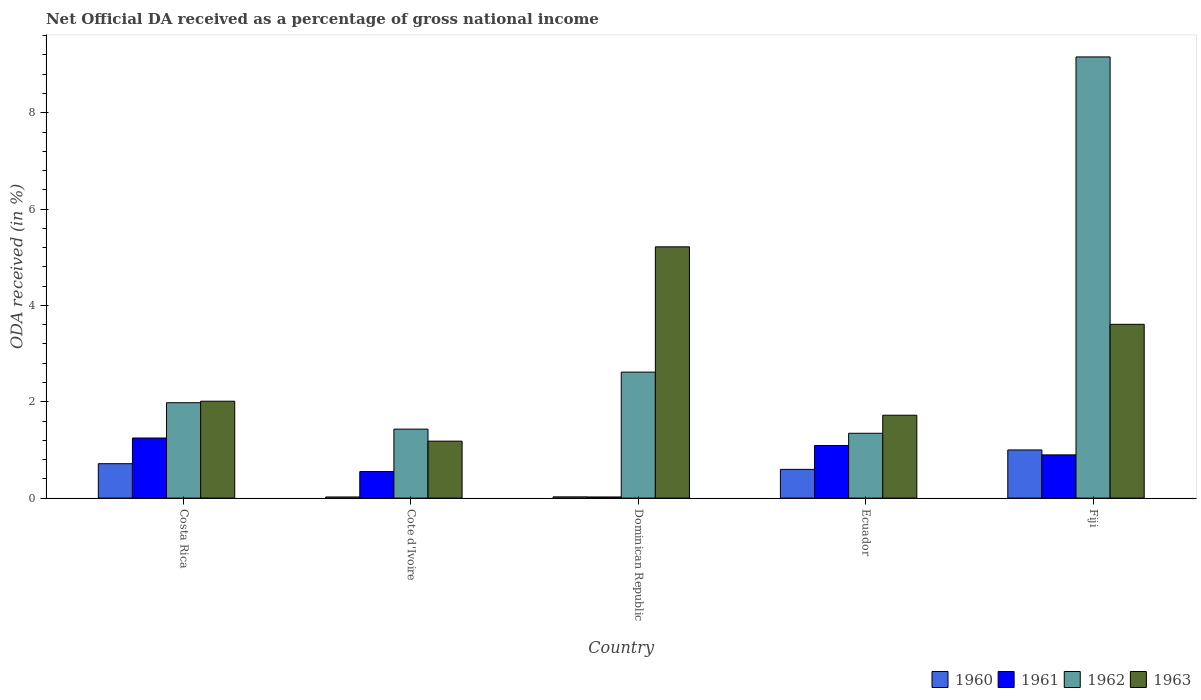How many groups of bars are there?
Keep it short and to the point. 5. Are the number of bars on each tick of the X-axis equal?
Offer a terse response. Yes. How many bars are there on the 1st tick from the right?
Your response must be concise. 4. What is the net official DA received in 1962 in Ecuador?
Offer a very short reply. 1.35. Across all countries, what is the maximum net official DA received in 1961?
Keep it short and to the point. 1.25. Across all countries, what is the minimum net official DA received in 1960?
Provide a short and direct response. 0.02. In which country was the net official DA received in 1960 maximum?
Provide a succinct answer. Fiji. In which country was the net official DA received in 1963 minimum?
Give a very brief answer. Cote d'Ivoire. What is the total net official DA received in 1963 in the graph?
Your answer should be compact. 13.74. What is the difference between the net official DA received in 1960 in Costa Rica and that in Dominican Republic?
Make the answer very short. 0.69. What is the difference between the net official DA received in 1960 in Dominican Republic and the net official DA received in 1963 in Cote d'Ivoire?
Your response must be concise. -1.16. What is the average net official DA received in 1963 per country?
Ensure brevity in your answer.  2.75. What is the difference between the net official DA received of/in 1963 and net official DA received of/in 1961 in Cote d'Ivoire?
Provide a short and direct response. 0.63. What is the ratio of the net official DA received in 1961 in Costa Rica to that in Cote d'Ivoire?
Your answer should be very brief. 2.26. Is the difference between the net official DA received in 1963 in Cote d'Ivoire and Fiji greater than the difference between the net official DA received in 1961 in Cote d'Ivoire and Fiji?
Provide a succinct answer. No. What is the difference between the highest and the second highest net official DA received in 1960?
Your answer should be very brief. 0.29. What is the difference between the highest and the lowest net official DA received in 1960?
Provide a succinct answer. 0.98. In how many countries, is the net official DA received in 1961 greater than the average net official DA received in 1961 taken over all countries?
Make the answer very short. 3. Is the sum of the net official DA received in 1960 in Ecuador and Fiji greater than the maximum net official DA received in 1962 across all countries?
Keep it short and to the point. No. What does the 3rd bar from the left in Cote d'Ivoire represents?
Make the answer very short. 1962. What does the 1st bar from the right in Dominican Republic represents?
Offer a terse response. 1963. Is it the case that in every country, the sum of the net official DA received in 1961 and net official DA received in 1962 is greater than the net official DA received in 1963?
Offer a terse response. No. How many bars are there?
Provide a succinct answer. 20. Are all the bars in the graph horizontal?
Ensure brevity in your answer.  No. How many countries are there in the graph?
Give a very brief answer. 5. What is the difference between two consecutive major ticks on the Y-axis?
Ensure brevity in your answer.  2. Are the values on the major ticks of Y-axis written in scientific E-notation?
Your response must be concise. No. Does the graph contain grids?
Provide a succinct answer. No. How many legend labels are there?
Provide a short and direct response. 4. What is the title of the graph?
Offer a very short reply. Net Official DA received as a percentage of gross national income. What is the label or title of the Y-axis?
Offer a terse response. ODA received (in %). What is the ODA received (in %) of 1960 in Costa Rica?
Give a very brief answer. 0.71. What is the ODA received (in %) in 1961 in Costa Rica?
Keep it short and to the point. 1.25. What is the ODA received (in %) of 1962 in Costa Rica?
Ensure brevity in your answer.  1.98. What is the ODA received (in %) of 1963 in Costa Rica?
Offer a terse response. 2.01. What is the ODA received (in %) of 1960 in Cote d'Ivoire?
Provide a short and direct response. 0.02. What is the ODA received (in %) in 1961 in Cote d'Ivoire?
Provide a short and direct response. 0.55. What is the ODA received (in %) in 1962 in Cote d'Ivoire?
Provide a short and direct response. 1.43. What is the ODA received (in %) of 1963 in Cote d'Ivoire?
Ensure brevity in your answer.  1.18. What is the ODA received (in %) in 1960 in Dominican Republic?
Give a very brief answer. 0.03. What is the ODA received (in %) of 1961 in Dominican Republic?
Keep it short and to the point. 0.02. What is the ODA received (in %) of 1962 in Dominican Republic?
Provide a short and direct response. 2.62. What is the ODA received (in %) in 1963 in Dominican Republic?
Give a very brief answer. 5.22. What is the ODA received (in %) in 1960 in Ecuador?
Ensure brevity in your answer.  0.6. What is the ODA received (in %) in 1961 in Ecuador?
Provide a succinct answer. 1.09. What is the ODA received (in %) of 1962 in Ecuador?
Offer a very short reply. 1.35. What is the ODA received (in %) in 1963 in Ecuador?
Offer a terse response. 1.72. What is the ODA received (in %) of 1960 in Fiji?
Make the answer very short. 1. What is the ODA received (in %) of 1961 in Fiji?
Your answer should be compact. 0.9. What is the ODA received (in %) in 1962 in Fiji?
Offer a very short reply. 9.16. What is the ODA received (in %) in 1963 in Fiji?
Your answer should be very brief. 3.61. Across all countries, what is the maximum ODA received (in %) of 1960?
Your response must be concise. 1. Across all countries, what is the maximum ODA received (in %) in 1961?
Provide a short and direct response. 1.25. Across all countries, what is the maximum ODA received (in %) of 1962?
Your answer should be compact. 9.16. Across all countries, what is the maximum ODA received (in %) in 1963?
Your answer should be very brief. 5.22. Across all countries, what is the minimum ODA received (in %) in 1960?
Give a very brief answer. 0.02. Across all countries, what is the minimum ODA received (in %) of 1961?
Provide a succinct answer. 0.02. Across all countries, what is the minimum ODA received (in %) of 1962?
Give a very brief answer. 1.35. Across all countries, what is the minimum ODA received (in %) of 1963?
Offer a very short reply. 1.18. What is the total ODA received (in %) in 1960 in the graph?
Offer a terse response. 2.36. What is the total ODA received (in %) in 1961 in the graph?
Ensure brevity in your answer.  3.81. What is the total ODA received (in %) in 1962 in the graph?
Provide a short and direct response. 16.53. What is the total ODA received (in %) of 1963 in the graph?
Make the answer very short. 13.74. What is the difference between the ODA received (in %) in 1960 in Costa Rica and that in Cote d'Ivoire?
Your answer should be very brief. 0.69. What is the difference between the ODA received (in %) in 1961 in Costa Rica and that in Cote d'Ivoire?
Your answer should be compact. 0.7. What is the difference between the ODA received (in %) of 1962 in Costa Rica and that in Cote d'Ivoire?
Ensure brevity in your answer.  0.55. What is the difference between the ODA received (in %) of 1963 in Costa Rica and that in Cote d'Ivoire?
Provide a succinct answer. 0.83. What is the difference between the ODA received (in %) of 1960 in Costa Rica and that in Dominican Republic?
Keep it short and to the point. 0.69. What is the difference between the ODA received (in %) in 1961 in Costa Rica and that in Dominican Republic?
Provide a short and direct response. 1.22. What is the difference between the ODA received (in %) of 1962 in Costa Rica and that in Dominican Republic?
Provide a succinct answer. -0.64. What is the difference between the ODA received (in %) in 1963 in Costa Rica and that in Dominican Republic?
Make the answer very short. -3.21. What is the difference between the ODA received (in %) in 1960 in Costa Rica and that in Ecuador?
Make the answer very short. 0.12. What is the difference between the ODA received (in %) of 1961 in Costa Rica and that in Ecuador?
Keep it short and to the point. 0.16. What is the difference between the ODA received (in %) in 1962 in Costa Rica and that in Ecuador?
Keep it short and to the point. 0.63. What is the difference between the ODA received (in %) in 1963 in Costa Rica and that in Ecuador?
Your answer should be compact. 0.29. What is the difference between the ODA received (in %) of 1960 in Costa Rica and that in Fiji?
Your answer should be compact. -0.29. What is the difference between the ODA received (in %) in 1961 in Costa Rica and that in Fiji?
Provide a short and direct response. 0.35. What is the difference between the ODA received (in %) of 1962 in Costa Rica and that in Fiji?
Your answer should be very brief. -7.18. What is the difference between the ODA received (in %) of 1963 in Costa Rica and that in Fiji?
Keep it short and to the point. -1.6. What is the difference between the ODA received (in %) of 1960 in Cote d'Ivoire and that in Dominican Republic?
Ensure brevity in your answer.  -0. What is the difference between the ODA received (in %) of 1961 in Cote d'Ivoire and that in Dominican Republic?
Provide a succinct answer. 0.53. What is the difference between the ODA received (in %) in 1962 in Cote d'Ivoire and that in Dominican Republic?
Make the answer very short. -1.18. What is the difference between the ODA received (in %) of 1963 in Cote d'Ivoire and that in Dominican Republic?
Give a very brief answer. -4.03. What is the difference between the ODA received (in %) in 1960 in Cote d'Ivoire and that in Ecuador?
Ensure brevity in your answer.  -0.57. What is the difference between the ODA received (in %) of 1961 in Cote d'Ivoire and that in Ecuador?
Provide a succinct answer. -0.54. What is the difference between the ODA received (in %) of 1962 in Cote d'Ivoire and that in Ecuador?
Offer a very short reply. 0.09. What is the difference between the ODA received (in %) in 1963 in Cote d'Ivoire and that in Ecuador?
Your answer should be very brief. -0.54. What is the difference between the ODA received (in %) of 1960 in Cote d'Ivoire and that in Fiji?
Your answer should be very brief. -0.98. What is the difference between the ODA received (in %) in 1961 in Cote d'Ivoire and that in Fiji?
Make the answer very short. -0.35. What is the difference between the ODA received (in %) in 1962 in Cote d'Ivoire and that in Fiji?
Give a very brief answer. -7.73. What is the difference between the ODA received (in %) of 1963 in Cote d'Ivoire and that in Fiji?
Your response must be concise. -2.43. What is the difference between the ODA received (in %) in 1960 in Dominican Republic and that in Ecuador?
Keep it short and to the point. -0.57. What is the difference between the ODA received (in %) of 1961 in Dominican Republic and that in Ecuador?
Provide a short and direct response. -1.07. What is the difference between the ODA received (in %) in 1962 in Dominican Republic and that in Ecuador?
Provide a short and direct response. 1.27. What is the difference between the ODA received (in %) in 1963 in Dominican Republic and that in Ecuador?
Your response must be concise. 3.5. What is the difference between the ODA received (in %) of 1960 in Dominican Republic and that in Fiji?
Provide a succinct answer. -0.97. What is the difference between the ODA received (in %) of 1961 in Dominican Republic and that in Fiji?
Offer a terse response. -0.87. What is the difference between the ODA received (in %) in 1962 in Dominican Republic and that in Fiji?
Provide a short and direct response. -6.54. What is the difference between the ODA received (in %) in 1963 in Dominican Republic and that in Fiji?
Offer a very short reply. 1.61. What is the difference between the ODA received (in %) in 1960 in Ecuador and that in Fiji?
Provide a succinct answer. -0.4. What is the difference between the ODA received (in %) in 1961 in Ecuador and that in Fiji?
Give a very brief answer. 0.2. What is the difference between the ODA received (in %) of 1962 in Ecuador and that in Fiji?
Provide a short and direct response. -7.81. What is the difference between the ODA received (in %) of 1963 in Ecuador and that in Fiji?
Provide a succinct answer. -1.89. What is the difference between the ODA received (in %) of 1960 in Costa Rica and the ODA received (in %) of 1961 in Cote d'Ivoire?
Your answer should be compact. 0.16. What is the difference between the ODA received (in %) in 1960 in Costa Rica and the ODA received (in %) in 1962 in Cote d'Ivoire?
Your answer should be very brief. -0.72. What is the difference between the ODA received (in %) in 1960 in Costa Rica and the ODA received (in %) in 1963 in Cote d'Ivoire?
Keep it short and to the point. -0.47. What is the difference between the ODA received (in %) in 1961 in Costa Rica and the ODA received (in %) in 1962 in Cote d'Ivoire?
Provide a succinct answer. -0.18. What is the difference between the ODA received (in %) in 1961 in Costa Rica and the ODA received (in %) in 1963 in Cote d'Ivoire?
Give a very brief answer. 0.07. What is the difference between the ODA received (in %) of 1962 in Costa Rica and the ODA received (in %) of 1963 in Cote d'Ivoire?
Offer a very short reply. 0.8. What is the difference between the ODA received (in %) of 1960 in Costa Rica and the ODA received (in %) of 1961 in Dominican Republic?
Make the answer very short. 0.69. What is the difference between the ODA received (in %) in 1960 in Costa Rica and the ODA received (in %) in 1962 in Dominican Republic?
Keep it short and to the point. -1.9. What is the difference between the ODA received (in %) of 1960 in Costa Rica and the ODA received (in %) of 1963 in Dominican Republic?
Ensure brevity in your answer.  -4.5. What is the difference between the ODA received (in %) in 1961 in Costa Rica and the ODA received (in %) in 1962 in Dominican Republic?
Offer a very short reply. -1.37. What is the difference between the ODA received (in %) in 1961 in Costa Rica and the ODA received (in %) in 1963 in Dominican Republic?
Provide a short and direct response. -3.97. What is the difference between the ODA received (in %) in 1962 in Costa Rica and the ODA received (in %) in 1963 in Dominican Republic?
Ensure brevity in your answer.  -3.24. What is the difference between the ODA received (in %) of 1960 in Costa Rica and the ODA received (in %) of 1961 in Ecuador?
Keep it short and to the point. -0.38. What is the difference between the ODA received (in %) in 1960 in Costa Rica and the ODA received (in %) in 1962 in Ecuador?
Ensure brevity in your answer.  -0.63. What is the difference between the ODA received (in %) of 1960 in Costa Rica and the ODA received (in %) of 1963 in Ecuador?
Ensure brevity in your answer.  -1.01. What is the difference between the ODA received (in %) of 1961 in Costa Rica and the ODA received (in %) of 1962 in Ecuador?
Your answer should be very brief. -0.1. What is the difference between the ODA received (in %) in 1961 in Costa Rica and the ODA received (in %) in 1963 in Ecuador?
Provide a short and direct response. -0.47. What is the difference between the ODA received (in %) in 1962 in Costa Rica and the ODA received (in %) in 1963 in Ecuador?
Keep it short and to the point. 0.26. What is the difference between the ODA received (in %) in 1960 in Costa Rica and the ODA received (in %) in 1961 in Fiji?
Offer a very short reply. -0.18. What is the difference between the ODA received (in %) of 1960 in Costa Rica and the ODA received (in %) of 1962 in Fiji?
Provide a succinct answer. -8.45. What is the difference between the ODA received (in %) in 1960 in Costa Rica and the ODA received (in %) in 1963 in Fiji?
Provide a short and direct response. -2.89. What is the difference between the ODA received (in %) of 1961 in Costa Rica and the ODA received (in %) of 1962 in Fiji?
Offer a very short reply. -7.91. What is the difference between the ODA received (in %) in 1961 in Costa Rica and the ODA received (in %) in 1963 in Fiji?
Your response must be concise. -2.36. What is the difference between the ODA received (in %) in 1962 in Costa Rica and the ODA received (in %) in 1963 in Fiji?
Ensure brevity in your answer.  -1.63. What is the difference between the ODA received (in %) of 1960 in Cote d'Ivoire and the ODA received (in %) of 1961 in Dominican Republic?
Provide a short and direct response. -0. What is the difference between the ODA received (in %) in 1960 in Cote d'Ivoire and the ODA received (in %) in 1962 in Dominican Republic?
Ensure brevity in your answer.  -2.59. What is the difference between the ODA received (in %) in 1960 in Cote d'Ivoire and the ODA received (in %) in 1963 in Dominican Republic?
Offer a terse response. -5.19. What is the difference between the ODA received (in %) of 1961 in Cote d'Ivoire and the ODA received (in %) of 1962 in Dominican Republic?
Ensure brevity in your answer.  -2.06. What is the difference between the ODA received (in %) in 1961 in Cote d'Ivoire and the ODA received (in %) in 1963 in Dominican Republic?
Your response must be concise. -4.67. What is the difference between the ODA received (in %) in 1962 in Cote d'Ivoire and the ODA received (in %) in 1963 in Dominican Republic?
Your answer should be very brief. -3.79. What is the difference between the ODA received (in %) in 1960 in Cote d'Ivoire and the ODA received (in %) in 1961 in Ecuador?
Make the answer very short. -1.07. What is the difference between the ODA received (in %) of 1960 in Cote d'Ivoire and the ODA received (in %) of 1962 in Ecuador?
Your answer should be very brief. -1.32. What is the difference between the ODA received (in %) in 1960 in Cote d'Ivoire and the ODA received (in %) in 1963 in Ecuador?
Ensure brevity in your answer.  -1.7. What is the difference between the ODA received (in %) in 1961 in Cote d'Ivoire and the ODA received (in %) in 1962 in Ecuador?
Provide a short and direct response. -0.79. What is the difference between the ODA received (in %) in 1961 in Cote d'Ivoire and the ODA received (in %) in 1963 in Ecuador?
Give a very brief answer. -1.17. What is the difference between the ODA received (in %) in 1962 in Cote d'Ivoire and the ODA received (in %) in 1963 in Ecuador?
Give a very brief answer. -0.29. What is the difference between the ODA received (in %) in 1960 in Cote d'Ivoire and the ODA received (in %) in 1961 in Fiji?
Give a very brief answer. -0.87. What is the difference between the ODA received (in %) in 1960 in Cote d'Ivoire and the ODA received (in %) in 1962 in Fiji?
Your response must be concise. -9.14. What is the difference between the ODA received (in %) of 1960 in Cote d'Ivoire and the ODA received (in %) of 1963 in Fiji?
Give a very brief answer. -3.58. What is the difference between the ODA received (in %) of 1961 in Cote d'Ivoire and the ODA received (in %) of 1962 in Fiji?
Provide a short and direct response. -8.61. What is the difference between the ODA received (in %) of 1961 in Cote d'Ivoire and the ODA received (in %) of 1963 in Fiji?
Your response must be concise. -3.06. What is the difference between the ODA received (in %) in 1962 in Cote d'Ivoire and the ODA received (in %) in 1963 in Fiji?
Your answer should be very brief. -2.18. What is the difference between the ODA received (in %) in 1960 in Dominican Republic and the ODA received (in %) in 1961 in Ecuador?
Your response must be concise. -1.07. What is the difference between the ODA received (in %) in 1960 in Dominican Republic and the ODA received (in %) in 1962 in Ecuador?
Provide a succinct answer. -1.32. What is the difference between the ODA received (in %) of 1960 in Dominican Republic and the ODA received (in %) of 1963 in Ecuador?
Your answer should be very brief. -1.69. What is the difference between the ODA received (in %) of 1961 in Dominican Republic and the ODA received (in %) of 1962 in Ecuador?
Your answer should be very brief. -1.32. What is the difference between the ODA received (in %) in 1961 in Dominican Republic and the ODA received (in %) in 1963 in Ecuador?
Provide a succinct answer. -1.7. What is the difference between the ODA received (in %) of 1962 in Dominican Republic and the ODA received (in %) of 1963 in Ecuador?
Give a very brief answer. 0.9. What is the difference between the ODA received (in %) of 1960 in Dominican Republic and the ODA received (in %) of 1961 in Fiji?
Your answer should be very brief. -0.87. What is the difference between the ODA received (in %) in 1960 in Dominican Republic and the ODA received (in %) in 1962 in Fiji?
Your answer should be compact. -9.13. What is the difference between the ODA received (in %) in 1960 in Dominican Republic and the ODA received (in %) in 1963 in Fiji?
Provide a short and direct response. -3.58. What is the difference between the ODA received (in %) of 1961 in Dominican Republic and the ODA received (in %) of 1962 in Fiji?
Give a very brief answer. -9.14. What is the difference between the ODA received (in %) in 1961 in Dominican Republic and the ODA received (in %) in 1963 in Fiji?
Offer a very short reply. -3.58. What is the difference between the ODA received (in %) in 1962 in Dominican Republic and the ODA received (in %) in 1963 in Fiji?
Your answer should be very brief. -0.99. What is the difference between the ODA received (in %) in 1960 in Ecuador and the ODA received (in %) in 1961 in Fiji?
Your response must be concise. -0.3. What is the difference between the ODA received (in %) in 1960 in Ecuador and the ODA received (in %) in 1962 in Fiji?
Offer a terse response. -8.56. What is the difference between the ODA received (in %) of 1960 in Ecuador and the ODA received (in %) of 1963 in Fiji?
Your answer should be very brief. -3.01. What is the difference between the ODA received (in %) in 1961 in Ecuador and the ODA received (in %) in 1962 in Fiji?
Your response must be concise. -8.07. What is the difference between the ODA received (in %) in 1961 in Ecuador and the ODA received (in %) in 1963 in Fiji?
Offer a terse response. -2.52. What is the difference between the ODA received (in %) in 1962 in Ecuador and the ODA received (in %) in 1963 in Fiji?
Your answer should be very brief. -2.26. What is the average ODA received (in %) in 1960 per country?
Ensure brevity in your answer.  0.47. What is the average ODA received (in %) in 1961 per country?
Keep it short and to the point. 0.76. What is the average ODA received (in %) in 1962 per country?
Offer a very short reply. 3.31. What is the average ODA received (in %) in 1963 per country?
Your answer should be very brief. 2.75. What is the difference between the ODA received (in %) of 1960 and ODA received (in %) of 1961 in Costa Rica?
Give a very brief answer. -0.53. What is the difference between the ODA received (in %) in 1960 and ODA received (in %) in 1962 in Costa Rica?
Your response must be concise. -1.27. What is the difference between the ODA received (in %) in 1960 and ODA received (in %) in 1963 in Costa Rica?
Provide a succinct answer. -1.3. What is the difference between the ODA received (in %) in 1961 and ODA received (in %) in 1962 in Costa Rica?
Give a very brief answer. -0.73. What is the difference between the ODA received (in %) in 1961 and ODA received (in %) in 1963 in Costa Rica?
Keep it short and to the point. -0.76. What is the difference between the ODA received (in %) of 1962 and ODA received (in %) of 1963 in Costa Rica?
Your response must be concise. -0.03. What is the difference between the ODA received (in %) of 1960 and ODA received (in %) of 1961 in Cote d'Ivoire?
Give a very brief answer. -0.53. What is the difference between the ODA received (in %) in 1960 and ODA received (in %) in 1962 in Cote d'Ivoire?
Give a very brief answer. -1.41. What is the difference between the ODA received (in %) of 1960 and ODA received (in %) of 1963 in Cote d'Ivoire?
Ensure brevity in your answer.  -1.16. What is the difference between the ODA received (in %) in 1961 and ODA received (in %) in 1962 in Cote d'Ivoire?
Your answer should be compact. -0.88. What is the difference between the ODA received (in %) of 1961 and ODA received (in %) of 1963 in Cote d'Ivoire?
Ensure brevity in your answer.  -0.63. What is the difference between the ODA received (in %) of 1962 and ODA received (in %) of 1963 in Cote d'Ivoire?
Your answer should be very brief. 0.25. What is the difference between the ODA received (in %) of 1960 and ODA received (in %) of 1961 in Dominican Republic?
Ensure brevity in your answer.  0. What is the difference between the ODA received (in %) in 1960 and ODA received (in %) in 1962 in Dominican Republic?
Provide a succinct answer. -2.59. What is the difference between the ODA received (in %) of 1960 and ODA received (in %) of 1963 in Dominican Republic?
Your answer should be compact. -5.19. What is the difference between the ODA received (in %) of 1961 and ODA received (in %) of 1962 in Dominican Republic?
Your answer should be very brief. -2.59. What is the difference between the ODA received (in %) of 1961 and ODA received (in %) of 1963 in Dominican Republic?
Offer a terse response. -5.19. What is the difference between the ODA received (in %) in 1962 and ODA received (in %) in 1963 in Dominican Republic?
Your answer should be compact. -2.6. What is the difference between the ODA received (in %) of 1960 and ODA received (in %) of 1961 in Ecuador?
Make the answer very short. -0.5. What is the difference between the ODA received (in %) in 1960 and ODA received (in %) in 1962 in Ecuador?
Give a very brief answer. -0.75. What is the difference between the ODA received (in %) of 1960 and ODA received (in %) of 1963 in Ecuador?
Keep it short and to the point. -1.12. What is the difference between the ODA received (in %) of 1961 and ODA received (in %) of 1962 in Ecuador?
Provide a short and direct response. -0.25. What is the difference between the ODA received (in %) of 1961 and ODA received (in %) of 1963 in Ecuador?
Offer a terse response. -0.63. What is the difference between the ODA received (in %) of 1962 and ODA received (in %) of 1963 in Ecuador?
Ensure brevity in your answer.  -0.37. What is the difference between the ODA received (in %) in 1960 and ODA received (in %) in 1961 in Fiji?
Offer a terse response. 0.1. What is the difference between the ODA received (in %) in 1960 and ODA received (in %) in 1962 in Fiji?
Offer a very short reply. -8.16. What is the difference between the ODA received (in %) in 1960 and ODA received (in %) in 1963 in Fiji?
Your answer should be very brief. -2.61. What is the difference between the ODA received (in %) in 1961 and ODA received (in %) in 1962 in Fiji?
Offer a terse response. -8.26. What is the difference between the ODA received (in %) of 1961 and ODA received (in %) of 1963 in Fiji?
Your answer should be very brief. -2.71. What is the difference between the ODA received (in %) of 1962 and ODA received (in %) of 1963 in Fiji?
Your response must be concise. 5.55. What is the ratio of the ODA received (in %) in 1960 in Costa Rica to that in Cote d'Ivoire?
Your answer should be very brief. 30.57. What is the ratio of the ODA received (in %) of 1961 in Costa Rica to that in Cote d'Ivoire?
Provide a short and direct response. 2.26. What is the ratio of the ODA received (in %) of 1962 in Costa Rica to that in Cote d'Ivoire?
Provide a succinct answer. 1.38. What is the ratio of the ODA received (in %) of 1963 in Costa Rica to that in Cote d'Ivoire?
Make the answer very short. 1.7. What is the ratio of the ODA received (in %) in 1960 in Costa Rica to that in Dominican Republic?
Offer a terse response. 27.82. What is the ratio of the ODA received (in %) in 1961 in Costa Rica to that in Dominican Republic?
Your answer should be very brief. 52.85. What is the ratio of the ODA received (in %) of 1962 in Costa Rica to that in Dominican Republic?
Your answer should be compact. 0.76. What is the ratio of the ODA received (in %) in 1963 in Costa Rica to that in Dominican Republic?
Your response must be concise. 0.39. What is the ratio of the ODA received (in %) in 1960 in Costa Rica to that in Ecuador?
Offer a terse response. 1.2. What is the ratio of the ODA received (in %) in 1961 in Costa Rica to that in Ecuador?
Provide a succinct answer. 1.14. What is the ratio of the ODA received (in %) in 1962 in Costa Rica to that in Ecuador?
Your answer should be compact. 1.47. What is the ratio of the ODA received (in %) of 1963 in Costa Rica to that in Ecuador?
Your answer should be very brief. 1.17. What is the ratio of the ODA received (in %) of 1960 in Costa Rica to that in Fiji?
Give a very brief answer. 0.71. What is the ratio of the ODA received (in %) of 1961 in Costa Rica to that in Fiji?
Give a very brief answer. 1.39. What is the ratio of the ODA received (in %) of 1962 in Costa Rica to that in Fiji?
Ensure brevity in your answer.  0.22. What is the ratio of the ODA received (in %) in 1963 in Costa Rica to that in Fiji?
Provide a short and direct response. 0.56. What is the ratio of the ODA received (in %) in 1960 in Cote d'Ivoire to that in Dominican Republic?
Keep it short and to the point. 0.91. What is the ratio of the ODA received (in %) of 1961 in Cote d'Ivoire to that in Dominican Republic?
Your response must be concise. 23.38. What is the ratio of the ODA received (in %) in 1962 in Cote d'Ivoire to that in Dominican Republic?
Make the answer very short. 0.55. What is the ratio of the ODA received (in %) of 1963 in Cote d'Ivoire to that in Dominican Republic?
Your answer should be very brief. 0.23. What is the ratio of the ODA received (in %) of 1960 in Cote d'Ivoire to that in Ecuador?
Provide a short and direct response. 0.04. What is the ratio of the ODA received (in %) of 1961 in Cote d'Ivoire to that in Ecuador?
Keep it short and to the point. 0.51. What is the ratio of the ODA received (in %) of 1962 in Cote d'Ivoire to that in Ecuador?
Your response must be concise. 1.06. What is the ratio of the ODA received (in %) in 1963 in Cote d'Ivoire to that in Ecuador?
Give a very brief answer. 0.69. What is the ratio of the ODA received (in %) of 1960 in Cote d'Ivoire to that in Fiji?
Offer a terse response. 0.02. What is the ratio of the ODA received (in %) of 1961 in Cote d'Ivoire to that in Fiji?
Give a very brief answer. 0.61. What is the ratio of the ODA received (in %) of 1962 in Cote d'Ivoire to that in Fiji?
Your response must be concise. 0.16. What is the ratio of the ODA received (in %) of 1963 in Cote d'Ivoire to that in Fiji?
Provide a succinct answer. 0.33. What is the ratio of the ODA received (in %) in 1960 in Dominican Republic to that in Ecuador?
Your answer should be compact. 0.04. What is the ratio of the ODA received (in %) of 1961 in Dominican Republic to that in Ecuador?
Ensure brevity in your answer.  0.02. What is the ratio of the ODA received (in %) of 1962 in Dominican Republic to that in Ecuador?
Your response must be concise. 1.94. What is the ratio of the ODA received (in %) in 1963 in Dominican Republic to that in Ecuador?
Keep it short and to the point. 3.03. What is the ratio of the ODA received (in %) in 1960 in Dominican Republic to that in Fiji?
Your response must be concise. 0.03. What is the ratio of the ODA received (in %) in 1961 in Dominican Republic to that in Fiji?
Keep it short and to the point. 0.03. What is the ratio of the ODA received (in %) of 1962 in Dominican Republic to that in Fiji?
Make the answer very short. 0.29. What is the ratio of the ODA received (in %) in 1963 in Dominican Republic to that in Fiji?
Your answer should be very brief. 1.45. What is the ratio of the ODA received (in %) of 1960 in Ecuador to that in Fiji?
Make the answer very short. 0.6. What is the ratio of the ODA received (in %) in 1961 in Ecuador to that in Fiji?
Make the answer very short. 1.22. What is the ratio of the ODA received (in %) in 1962 in Ecuador to that in Fiji?
Your answer should be compact. 0.15. What is the ratio of the ODA received (in %) of 1963 in Ecuador to that in Fiji?
Ensure brevity in your answer.  0.48. What is the difference between the highest and the second highest ODA received (in %) of 1960?
Provide a short and direct response. 0.29. What is the difference between the highest and the second highest ODA received (in %) of 1961?
Your response must be concise. 0.16. What is the difference between the highest and the second highest ODA received (in %) in 1962?
Your answer should be compact. 6.54. What is the difference between the highest and the second highest ODA received (in %) of 1963?
Keep it short and to the point. 1.61. What is the difference between the highest and the lowest ODA received (in %) of 1960?
Keep it short and to the point. 0.98. What is the difference between the highest and the lowest ODA received (in %) of 1961?
Your answer should be very brief. 1.22. What is the difference between the highest and the lowest ODA received (in %) of 1962?
Provide a succinct answer. 7.81. What is the difference between the highest and the lowest ODA received (in %) of 1963?
Ensure brevity in your answer.  4.03. 